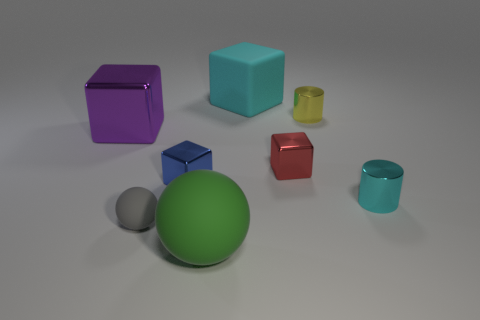What shape is the thing that is in front of the small red shiny thing and behind the small cyan shiny thing?
Give a very brief answer. Cube. What is the material of the small red cube?
Give a very brief answer. Metal. How many spheres are large purple things or blue shiny objects?
Give a very brief answer. 0. Is the blue block made of the same material as the small red block?
Offer a very short reply. Yes. What is the size of the cyan metallic thing that is the same shape as the tiny yellow metal thing?
Provide a short and direct response. Small. There is a large thing that is both to the right of the purple object and in front of the large rubber cube; what is its material?
Make the answer very short. Rubber. Are there an equal number of large shiny blocks that are to the right of the large purple shiny block and gray matte spheres?
Provide a short and direct response. No. How many objects are large blocks to the right of the tiny matte object or shiny objects?
Provide a succinct answer. 6. Does the small cube in front of the red metallic block have the same color as the tiny matte object?
Your answer should be compact. No. There is a cyan object that is to the right of the red object; what is its size?
Provide a succinct answer. Small. 